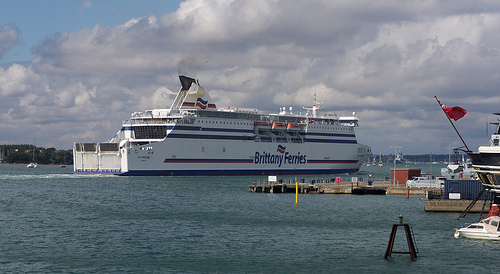What activities could you imagine happening near this ship and dock? Near this ship and dock, one could imagine a variety of activities such as passengers boarding and disembarking, tourists taking photos with the scenic backdrop of the ship and sea, and dock workers loading and unloading cargo. There could also be fishermen casting their lines from the pier and smaller boats departing for short excursions. How would you describe the mood and energy at this location? The mood at this location is a blend of excitement and serenity. The hustle and bustle of passengers and workers give it an energetic vibe, while the calm sea and gentle movement of the ship instill a sense of peace and relaxation. What kind of conversations might you overhear if you were standing on the pier? Standing on the pier, you might overhear conversations about travel plans and destinations as passengers discuss their upcoming journey. There could be enthusiastic chatter from tourists marveling at the ship and taking photos, along with logistical discussions among dock workers coordinating the ship's departure. Additionally, you might catch snippets of local fishermen discussing the best fishing spots and the day's catch. 